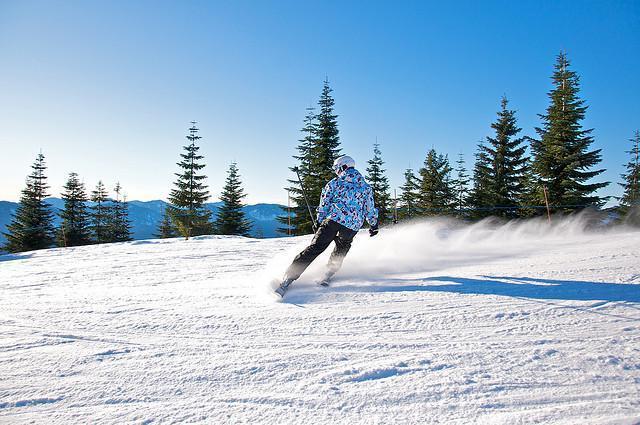How many airplanes do you see?
Give a very brief answer. 0. 